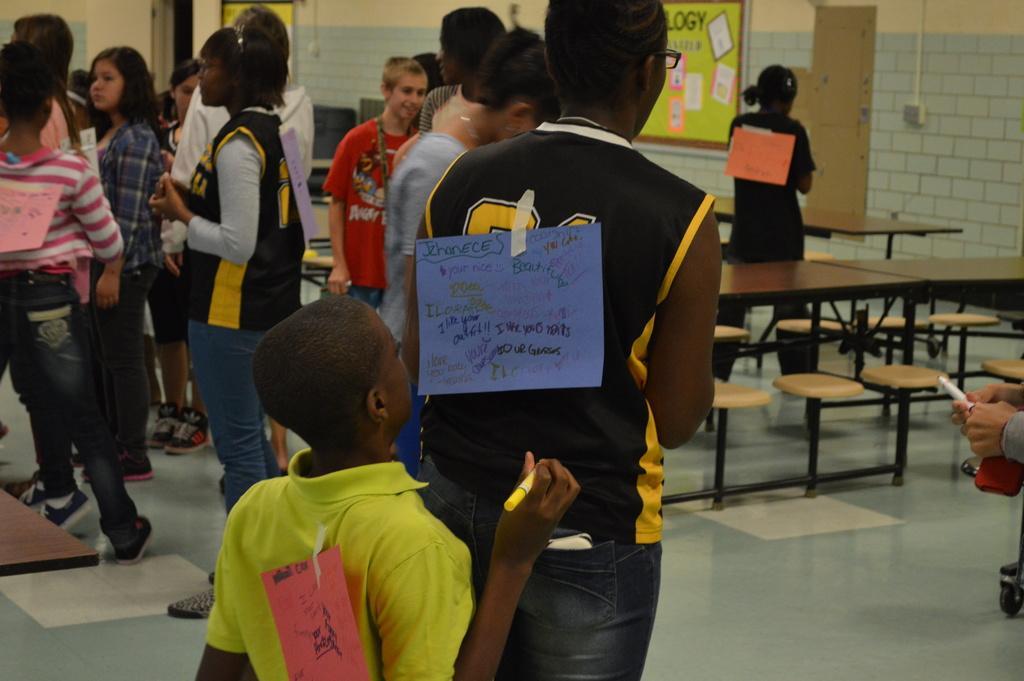Describe this image in one or two sentences. In this image we can see a person is standing and there is a paper attached to the back with texts written on it and behind there is another person holding a sketch in the hand and there is paper attached to his back. In the background we can see few persons and among them few persons are having papers attached to their backs, boards and objects on the wall and there are objects. 